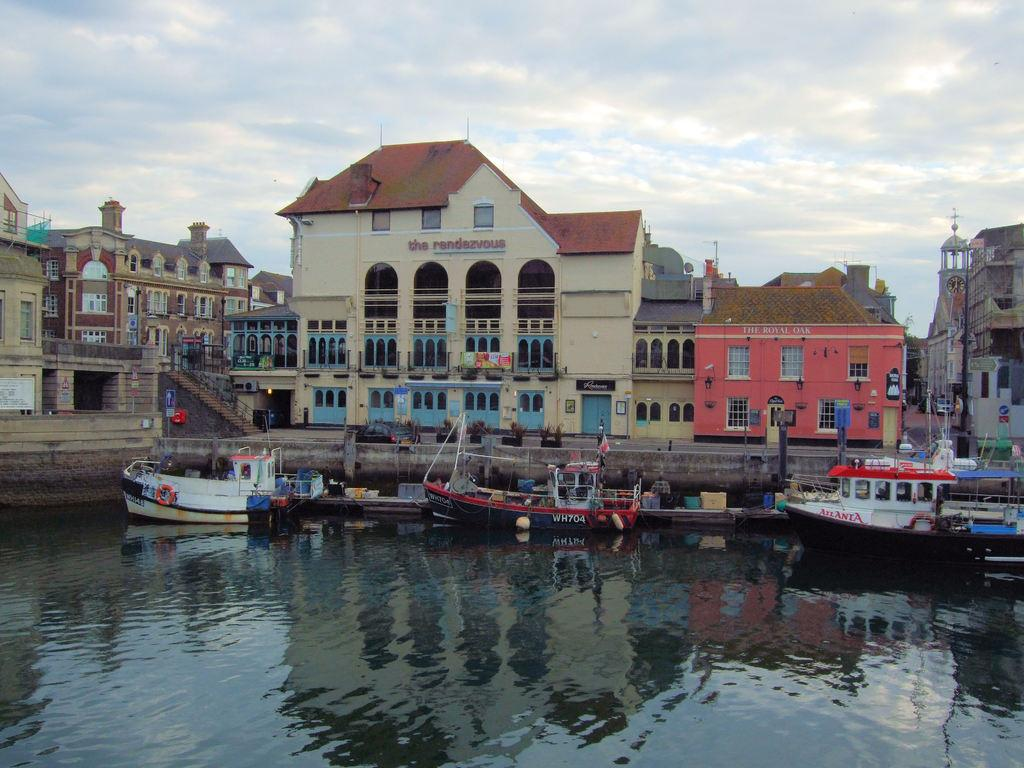<image>
Create a compact narrative representing the image presented. harbor boats and shops like The Royal Oak 